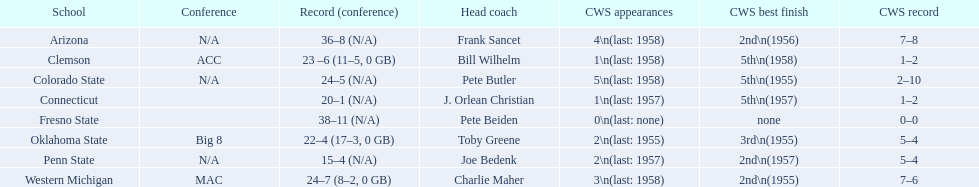What are all the school names? Arizona, Clemson, Colorado State, Connecticut, Fresno State, Oklahoma State, Penn State, Western Michigan. What is the record for each? 36–8 (N/A), 23 –6 (11–5, 0 GB), 24–5 (N/A), 20–1 (N/A), 38–11 (N/A), 22–4 (17–3, 0 GB), 15–4 (N/A), 24–7 (8–2, 0 GB). Which school had the fewest number of wins? Penn State. 